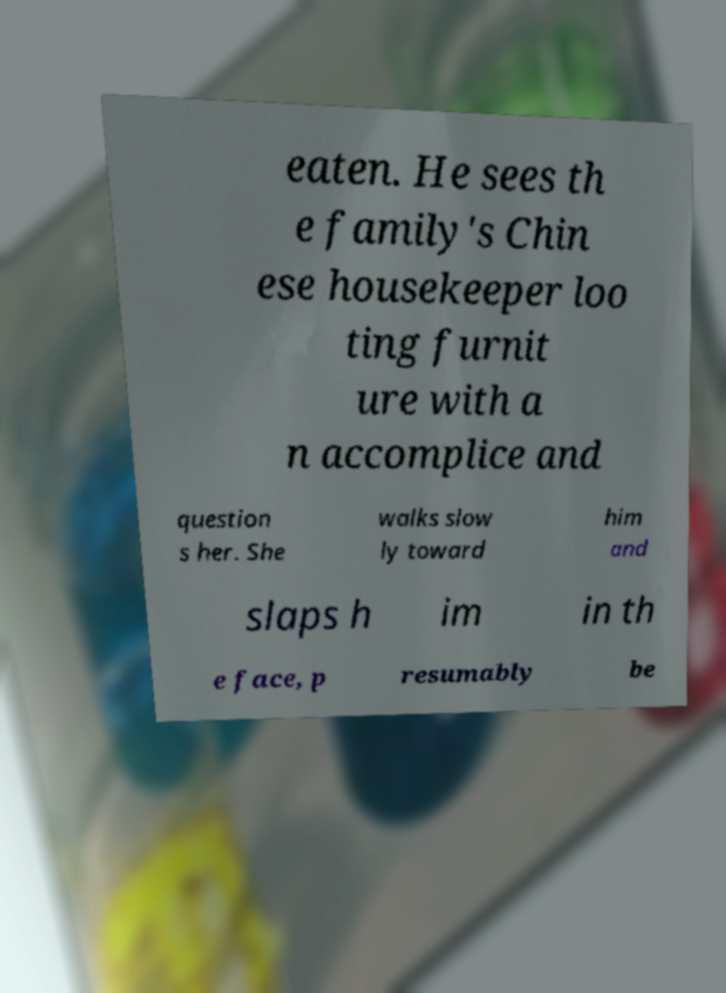What messages or text are displayed in this image? I need them in a readable, typed format. eaten. He sees th e family's Chin ese housekeeper loo ting furnit ure with a n accomplice and question s her. She walks slow ly toward him and slaps h im in th e face, p resumably be 